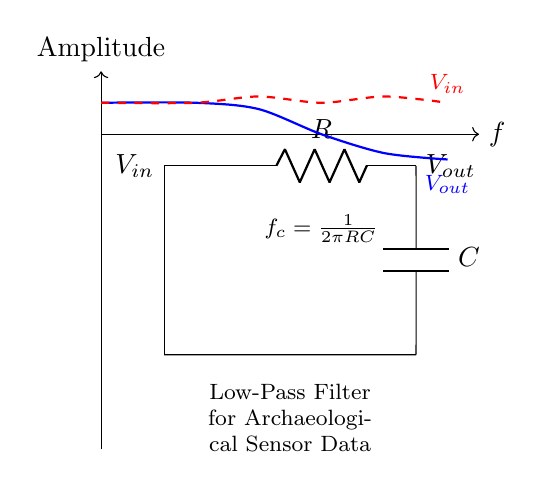What type of filter is represented in the circuit? The circuit is a low-pass filter, which allows signals with a frequency lower than a certain cutoff frequency to pass through and attenuates frequencies higher than that. This is evident from the configuration of the resistor and capacitor in series.
Answer: Low-pass filter What components are present in this circuit? The circuit includes a resistor and a capacitor, as indicated by the symbols R and C in the diagram. The connections and layout also confirm these components are indeed present in the circuit.
Answer: Resistor and capacitor What is the output voltage in the circuit? The output voltage is labeled as V_out, which is found at the point on the right side of the circuit after the capacitor. This indicates the voltage measured across the capacitor, which is standard for low-pass filters where output voltage is taken across the capacitor.
Answer: V_out What does the equation f_c = 1/(2πRC) represent? This equation denotes the cutoff frequency f_c of the low-pass filter, where R is the resistance and C is the capacitance. It defines the frequency at which the output voltage is reduced to 70.7% of the input voltage, thus characterizing the filter’s frequency response.
Answer: Cutoff frequency How does the diagram depict the frequency response? The circuit shows the frequency response with two curves; one representing the input voltage V_in and the other illustrating the output voltage V_out. The amplitude of V_out decreases for frequencies higher than the cutoff frequency, which is visually demonstrated in the curve plots.
Answer: Frequency response curves 